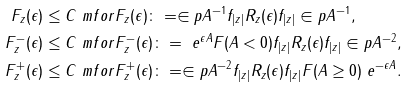<formula> <loc_0><loc_0><loc_500><loc_500>\| F _ { z } ( \epsilon ) \| & \leq C \ m f o r F _ { z } ( \epsilon ) \colon = \in p { A } ^ { - 1 } f _ { | z | } R _ { z } ( \epsilon ) f _ { | z | } \in p { A } ^ { - 1 } , \\ \| F ^ { - } _ { z } ( \epsilon ) \| & \leq C \ m f o r F ^ { - } _ { z } ( \epsilon ) \colon = \ e ^ { \epsilon A } F ( A < 0 ) f _ { | z | } R _ { z } ( \epsilon ) f _ { | z | } \in p { A } ^ { - 2 } , \\ \| F ^ { + } _ { z } ( \epsilon ) \| & \leq C \ m f o r F ^ { + } _ { z } ( \epsilon ) \colon = \in p { A } ^ { - 2 } f _ { | z | } R _ { z } ( \epsilon ) f _ { | z | } F ( A \geq 0 ) \ e ^ { - \epsilon A } .</formula> 